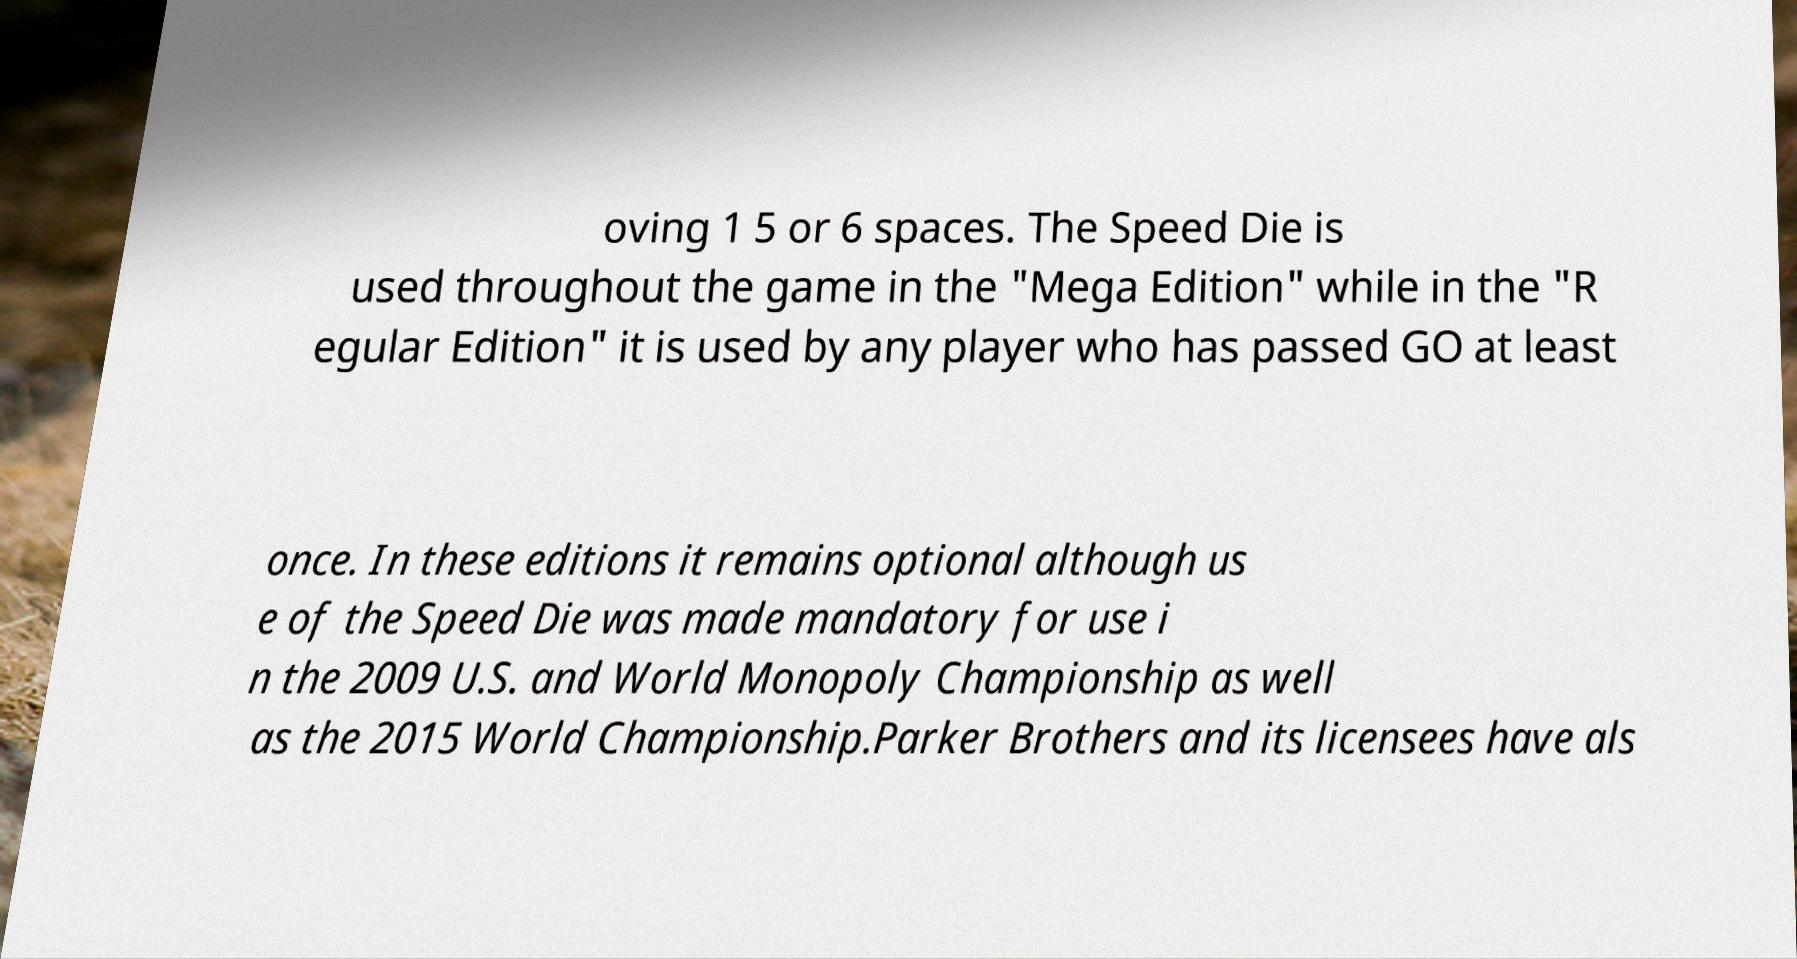What messages or text are displayed in this image? I need them in a readable, typed format. oving 1 5 or 6 spaces. The Speed Die is used throughout the game in the "Mega Edition" while in the "R egular Edition" it is used by any player who has passed GO at least once. In these editions it remains optional although us e of the Speed Die was made mandatory for use i n the 2009 U.S. and World Monopoly Championship as well as the 2015 World Championship.Parker Brothers and its licensees have als 